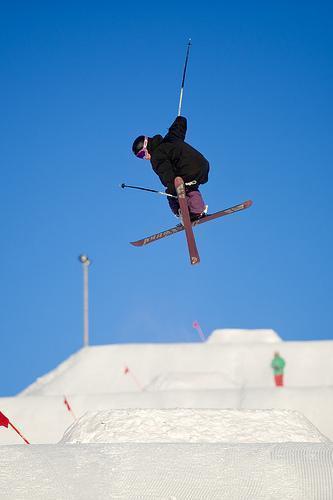How many red poles?
Give a very brief answer. 4. 